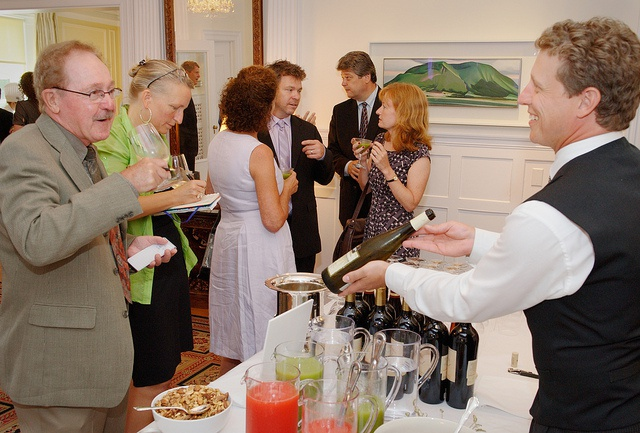Describe the objects in this image and their specific colors. I can see people in gray, black, lightgray, tan, and maroon tones, people in gray and salmon tones, people in gray, darkgray, and black tones, people in gray, black, tan, and brown tones, and dining table in gray, lightgray, and darkgray tones in this image. 